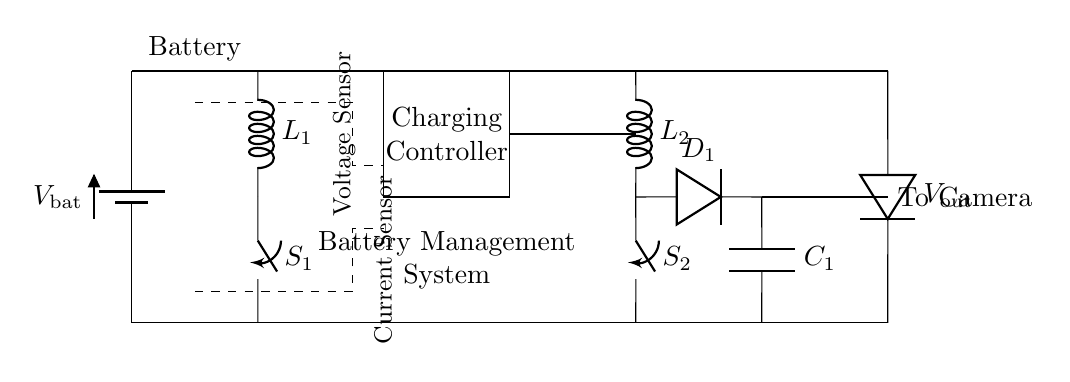What is the main purpose of the charging controller? The charging controller manages the charging process of the battery to ensure safety and efficiency. It regulates the voltage and current flowing into the battery during charging.
Answer: Charging management What type of circuit is represented here? This circuit is a battery management and charging circuit designed for portable camera equipment, which involves components like inductors, switches, and a charging controller.
Answer: Battery management circuit What are the two main sensors in this circuit? The circuit includes a voltage sensor and a current sensor, which are responsible for monitoring battery voltage and current to ensure proper battery management.
Answer: Voltage sensor and current sensor What does the boost converter do in this circuit? The boost converter steps up the voltage from the battery to a higher voltage suitable for powering the camera equipment, enabling it to function properly at the required operating voltage.
Answer: Steps up voltage How many inductors are present in the circuit? The circuit includes two inductors, labeled as L1 and L2, which are part of the charging and boost converter sections respectively.
Answer: Two What happens if the switch S1 is closed? Closing switch S1 allows current to flow through the circuit, enabling the charging process for the battery. This could potentially lead to the battery charging unless limited by other components.
Answer: Charging occurs What is the output voltage labeled in the circuit? The output voltage, represented as V_out, indicates the voltage supplied to the camera from the battery after processing through the charging circuit and boost converter.
Answer: V_out 